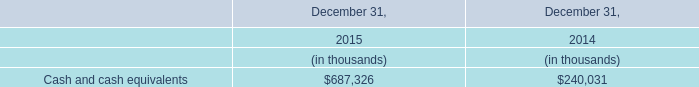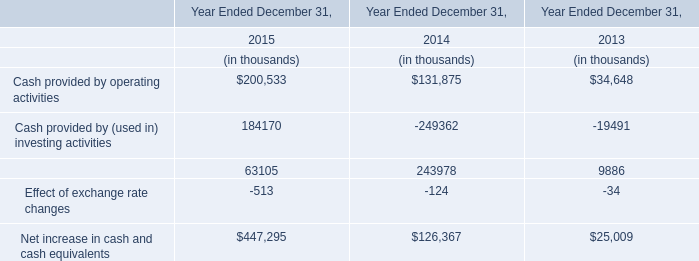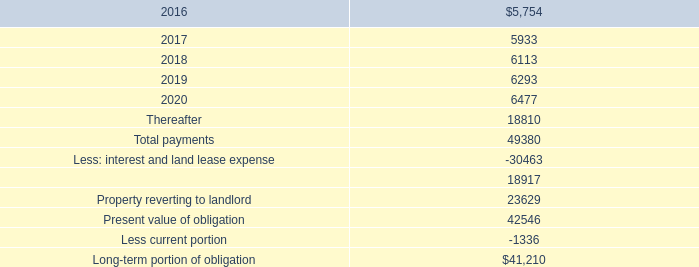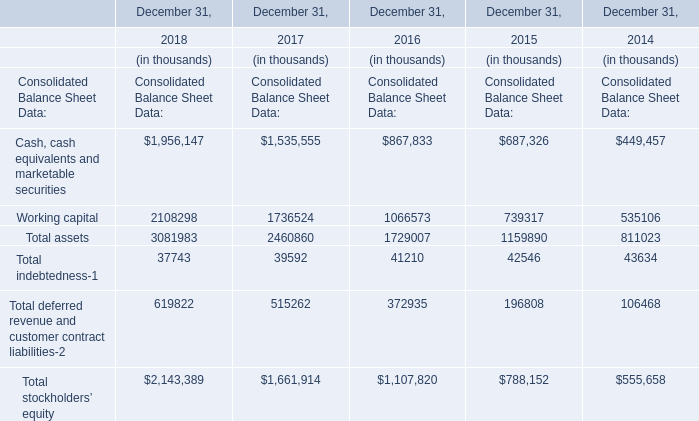What's the increasing rate of Total assets in 2018? 
Computations: (3081983 / (((((1956147 + 2108298) + 3081983) + 37743) + 619822) + 2143389))
Answer: 0.30983. 